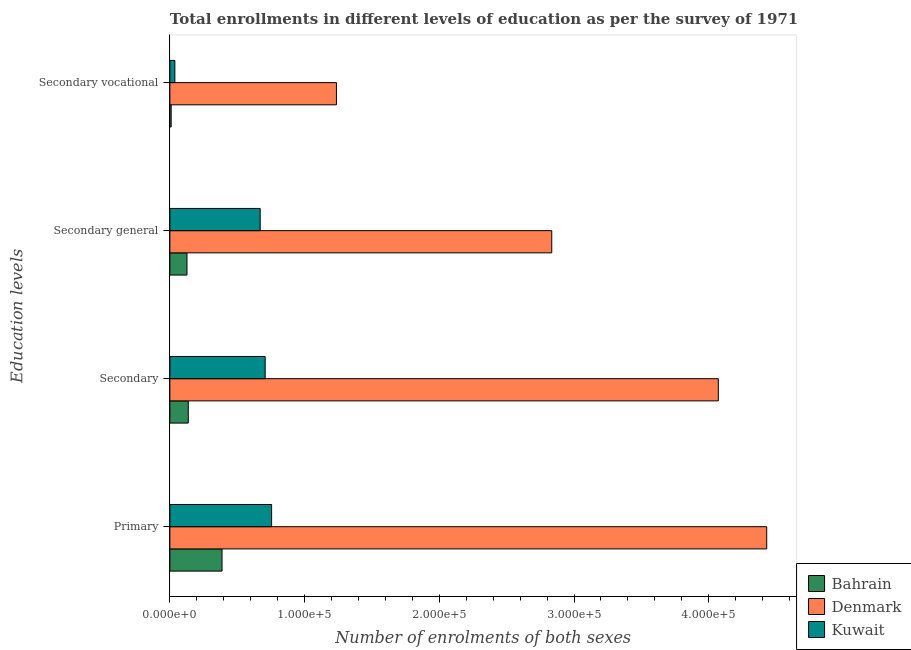How many different coloured bars are there?
Provide a succinct answer. 3. Are the number of bars per tick equal to the number of legend labels?
Make the answer very short. Yes. How many bars are there on the 3rd tick from the top?
Provide a succinct answer. 3. How many bars are there on the 3rd tick from the bottom?
Give a very brief answer. 3. What is the label of the 2nd group of bars from the top?
Give a very brief answer. Secondary general. What is the number of enrolments in secondary vocational education in Bahrain?
Ensure brevity in your answer.  955. Across all countries, what is the maximum number of enrolments in secondary general education?
Offer a very short reply. 2.83e+05. Across all countries, what is the minimum number of enrolments in secondary general education?
Your response must be concise. 1.27e+04. In which country was the number of enrolments in secondary vocational education maximum?
Your answer should be very brief. Denmark. In which country was the number of enrolments in primary education minimum?
Offer a very short reply. Bahrain. What is the total number of enrolments in secondary general education in the graph?
Make the answer very short. 3.63e+05. What is the difference between the number of enrolments in secondary vocational education in Bahrain and that in Kuwait?
Keep it short and to the point. -2741. What is the difference between the number of enrolments in secondary general education in Kuwait and the number of enrolments in secondary education in Denmark?
Keep it short and to the point. -3.40e+05. What is the average number of enrolments in primary education per country?
Provide a succinct answer. 1.86e+05. What is the difference between the number of enrolments in secondary general education and number of enrolments in primary education in Kuwait?
Offer a very short reply. -8475. In how many countries, is the number of enrolments in secondary general education greater than 320000 ?
Provide a short and direct response. 0. What is the ratio of the number of enrolments in secondary general education in Kuwait to that in Bahrain?
Give a very brief answer. 5.28. Is the number of enrolments in secondary education in Denmark less than that in Kuwait?
Give a very brief answer. No. Is the difference between the number of enrolments in secondary education in Bahrain and Denmark greater than the difference between the number of enrolments in primary education in Bahrain and Denmark?
Offer a very short reply. Yes. What is the difference between the highest and the second highest number of enrolments in secondary education?
Your answer should be very brief. 3.36e+05. What is the difference between the highest and the lowest number of enrolments in secondary general education?
Your answer should be very brief. 2.71e+05. In how many countries, is the number of enrolments in secondary education greater than the average number of enrolments in secondary education taken over all countries?
Provide a succinct answer. 1. Is the sum of the number of enrolments in secondary general education in Bahrain and Denmark greater than the maximum number of enrolments in primary education across all countries?
Offer a terse response. No. What does the 3rd bar from the top in Primary represents?
Your answer should be very brief. Bahrain. What does the 3rd bar from the bottom in Secondary general represents?
Ensure brevity in your answer.  Kuwait. Is it the case that in every country, the sum of the number of enrolments in primary education and number of enrolments in secondary education is greater than the number of enrolments in secondary general education?
Your response must be concise. Yes. How many bars are there?
Provide a short and direct response. 12. Are all the bars in the graph horizontal?
Keep it short and to the point. Yes. How many countries are there in the graph?
Offer a terse response. 3. What is the difference between two consecutive major ticks on the X-axis?
Give a very brief answer. 1.00e+05. Does the graph contain any zero values?
Offer a very short reply. No. How many legend labels are there?
Offer a very short reply. 3. What is the title of the graph?
Keep it short and to the point. Total enrollments in different levels of education as per the survey of 1971. What is the label or title of the X-axis?
Keep it short and to the point. Number of enrolments of both sexes. What is the label or title of the Y-axis?
Make the answer very short. Education levels. What is the Number of enrolments of both sexes in Bahrain in Primary?
Ensure brevity in your answer.  3.87e+04. What is the Number of enrolments of both sexes of Denmark in Primary?
Provide a short and direct response. 4.43e+05. What is the Number of enrolments of both sexes in Kuwait in Primary?
Give a very brief answer. 7.55e+04. What is the Number of enrolments of both sexes of Bahrain in Secondary?
Give a very brief answer. 1.37e+04. What is the Number of enrolments of both sexes of Denmark in Secondary?
Offer a very short reply. 4.07e+05. What is the Number of enrolments of both sexes in Kuwait in Secondary?
Make the answer very short. 7.07e+04. What is the Number of enrolments of both sexes of Bahrain in Secondary general?
Your response must be concise. 1.27e+04. What is the Number of enrolments of both sexes in Denmark in Secondary general?
Provide a succinct answer. 2.83e+05. What is the Number of enrolments of both sexes in Kuwait in Secondary general?
Ensure brevity in your answer.  6.70e+04. What is the Number of enrolments of both sexes in Bahrain in Secondary vocational?
Offer a terse response. 955. What is the Number of enrolments of both sexes of Denmark in Secondary vocational?
Your response must be concise. 1.24e+05. What is the Number of enrolments of both sexes in Kuwait in Secondary vocational?
Provide a short and direct response. 3696. Across all Education levels, what is the maximum Number of enrolments of both sexes in Bahrain?
Your response must be concise. 3.87e+04. Across all Education levels, what is the maximum Number of enrolments of both sexes of Denmark?
Ensure brevity in your answer.  4.43e+05. Across all Education levels, what is the maximum Number of enrolments of both sexes in Kuwait?
Provide a succinct answer. 7.55e+04. Across all Education levels, what is the minimum Number of enrolments of both sexes of Bahrain?
Your answer should be very brief. 955. Across all Education levels, what is the minimum Number of enrolments of both sexes in Denmark?
Make the answer very short. 1.24e+05. Across all Education levels, what is the minimum Number of enrolments of both sexes in Kuwait?
Provide a short and direct response. 3696. What is the total Number of enrolments of both sexes of Bahrain in the graph?
Offer a terse response. 6.60e+04. What is the total Number of enrolments of both sexes of Denmark in the graph?
Your answer should be very brief. 1.26e+06. What is the total Number of enrolments of both sexes in Kuwait in the graph?
Keep it short and to the point. 2.17e+05. What is the difference between the Number of enrolments of both sexes in Bahrain in Primary and that in Secondary?
Your answer should be compact. 2.51e+04. What is the difference between the Number of enrolments of both sexes in Denmark in Primary and that in Secondary?
Your response must be concise. 3.59e+04. What is the difference between the Number of enrolments of both sexes in Kuwait in Primary and that in Secondary?
Provide a short and direct response. 4779. What is the difference between the Number of enrolments of both sexes of Bahrain in Primary and that in Secondary general?
Keep it short and to the point. 2.60e+04. What is the difference between the Number of enrolments of both sexes in Denmark in Primary and that in Secondary general?
Your answer should be compact. 1.60e+05. What is the difference between the Number of enrolments of both sexes of Kuwait in Primary and that in Secondary general?
Your answer should be very brief. 8475. What is the difference between the Number of enrolments of both sexes in Bahrain in Primary and that in Secondary vocational?
Provide a succinct answer. 3.78e+04. What is the difference between the Number of enrolments of both sexes of Denmark in Primary and that in Secondary vocational?
Your answer should be very brief. 3.19e+05. What is the difference between the Number of enrolments of both sexes in Kuwait in Primary and that in Secondary vocational?
Keep it short and to the point. 7.18e+04. What is the difference between the Number of enrolments of both sexes in Bahrain in Secondary and that in Secondary general?
Your answer should be very brief. 955. What is the difference between the Number of enrolments of both sexes of Denmark in Secondary and that in Secondary general?
Your answer should be very brief. 1.24e+05. What is the difference between the Number of enrolments of both sexes of Kuwait in Secondary and that in Secondary general?
Provide a short and direct response. 3696. What is the difference between the Number of enrolments of both sexes in Bahrain in Secondary and that in Secondary vocational?
Your answer should be compact. 1.27e+04. What is the difference between the Number of enrolments of both sexes in Denmark in Secondary and that in Secondary vocational?
Your answer should be very brief. 2.83e+05. What is the difference between the Number of enrolments of both sexes of Kuwait in Secondary and that in Secondary vocational?
Offer a very short reply. 6.70e+04. What is the difference between the Number of enrolments of both sexes in Bahrain in Secondary general and that in Secondary vocational?
Your answer should be very brief. 1.17e+04. What is the difference between the Number of enrolments of both sexes of Denmark in Secondary general and that in Secondary vocational?
Ensure brevity in your answer.  1.60e+05. What is the difference between the Number of enrolments of both sexes in Kuwait in Secondary general and that in Secondary vocational?
Keep it short and to the point. 6.33e+04. What is the difference between the Number of enrolments of both sexes of Bahrain in Primary and the Number of enrolments of both sexes of Denmark in Secondary?
Make the answer very short. -3.68e+05. What is the difference between the Number of enrolments of both sexes in Bahrain in Primary and the Number of enrolments of both sexes in Kuwait in Secondary?
Ensure brevity in your answer.  -3.20e+04. What is the difference between the Number of enrolments of both sexes in Denmark in Primary and the Number of enrolments of both sexes in Kuwait in Secondary?
Ensure brevity in your answer.  3.72e+05. What is the difference between the Number of enrolments of both sexes of Bahrain in Primary and the Number of enrolments of both sexes of Denmark in Secondary general?
Your answer should be compact. -2.45e+05. What is the difference between the Number of enrolments of both sexes of Bahrain in Primary and the Number of enrolments of both sexes of Kuwait in Secondary general?
Keep it short and to the point. -2.83e+04. What is the difference between the Number of enrolments of both sexes in Denmark in Primary and the Number of enrolments of both sexes in Kuwait in Secondary general?
Provide a succinct answer. 3.76e+05. What is the difference between the Number of enrolments of both sexes of Bahrain in Primary and the Number of enrolments of both sexes of Denmark in Secondary vocational?
Your answer should be compact. -8.49e+04. What is the difference between the Number of enrolments of both sexes of Bahrain in Primary and the Number of enrolments of both sexes of Kuwait in Secondary vocational?
Your answer should be very brief. 3.50e+04. What is the difference between the Number of enrolments of both sexes of Denmark in Primary and the Number of enrolments of both sexes of Kuwait in Secondary vocational?
Give a very brief answer. 4.39e+05. What is the difference between the Number of enrolments of both sexes in Bahrain in Secondary and the Number of enrolments of both sexes in Denmark in Secondary general?
Provide a succinct answer. -2.70e+05. What is the difference between the Number of enrolments of both sexes in Bahrain in Secondary and the Number of enrolments of both sexes in Kuwait in Secondary general?
Offer a terse response. -5.34e+04. What is the difference between the Number of enrolments of both sexes of Denmark in Secondary and the Number of enrolments of both sexes of Kuwait in Secondary general?
Make the answer very short. 3.40e+05. What is the difference between the Number of enrolments of both sexes in Bahrain in Secondary and the Number of enrolments of both sexes in Denmark in Secondary vocational?
Make the answer very short. -1.10e+05. What is the difference between the Number of enrolments of both sexes of Bahrain in Secondary and the Number of enrolments of both sexes of Kuwait in Secondary vocational?
Offer a very short reply. 9956. What is the difference between the Number of enrolments of both sexes in Denmark in Secondary and the Number of enrolments of both sexes in Kuwait in Secondary vocational?
Offer a terse response. 4.03e+05. What is the difference between the Number of enrolments of both sexes in Bahrain in Secondary general and the Number of enrolments of both sexes in Denmark in Secondary vocational?
Offer a very short reply. -1.11e+05. What is the difference between the Number of enrolments of both sexes of Bahrain in Secondary general and the Number of enrolments of both sexes of Kuwait in Secondary vocational?
Provide a succinct answer. 9001. What is the difference between the Number of enrolments of both sexes in Denmark in Secondary general and the Number of enrolments of both sexes in Kuwait in Secondary vocational?
Ensure brevity in your answer.  2.80e+05. What is the average Number of enrolments of both sexes in Bahrain per Education levels?
Give a very brief answer. 1.65e+04. What is the average Number of enrolments of both sexes in Denmark per Education levels?
Ensure brevity in your answer.  3.14e+05. What is the average Number of enrolments of both sexes in Kuwait per Education levels?
Give a very brief answer. 5.42e+04. What is the difference between the Number of enrolments of both sexes of Bahrain and Number of enrolments of both sexes of Denmark in Primary?
Make the answer very short. -4.04e+05. What is the difference between the Number of enrolments of both sexes of Bahrain and Number of enrolments of both sexes of Kuwait in Primary?
Ensure brevity in your answer.  -3.68e+04. What is the difference between the Number of enrolments of both sexes in Denmark and Number of enrolments of both sexes in Kuwait in Primary?
Keep it short and to the point. 3.68e+05. What is the difference between the Number of enrolments of both sexes of Bahrain and Number of enrolments of both sexes of Denmark in Secondary?
Make the answer very short. -3.93e+05. What is the difference between the Number of enrolments of both sexes in Bahrain and Number of enrolments of both sexes in Kuwait in Secondary?
Ensure brevity in your answer.  -5.71e+04. What is the difference between the Number of enrolments of both sexes in Denmark and Number of enrolments of both sexes in Kuwait in Secondary?
Offer a terse response. 3.36e+05. What is the difference between the Number of enrolments of both sexes of Bahrain and Number of enrolments of both sexes of Denmark in Secondary general?
Your answer should be compact. -2.71e+05. What is the difference between the Number of enrolments of both sexes of Bahrain and Number of enrolments of both sexes of Kuwait in Secondary general?
Keep it short and to the point. -5.43e+04. What is the difference between the Number of enrolments of both sexes in Denmark and Number of enrolments of both sexes in Kuwait in Secondary general?
Your answer should be very brief. 2.16e+05. What is the difference between the Number of enrolments of both sexes in Bahrain and Number of enrolments of both sexes in Denmark in Secondary vocational?
Offer a very short reply. -1.23e+05. What is the difference between the Number of enrolments of both sexes in Bahrain and Number of enrolments of both sexes in Kuwait in Secondary vocational?
Your answer should be compact. -2741. What is the difference between the Number of enrolments of both sexes of Denmark and Number of enrolments of both sexes of Kuwait in Secondary vocational?
Give a very brief answer. 1.20e+05. What is the ratio of the Number of enrolments of both sexes in Bahrain in Primary to that in Secondary?
Keep it short and to the point. 2.84. What is the ratio of the Number of enrolments of both sexes in Denmark in Primary to that in Secondary?
Your answer should be very brief. 1.09. What is the ratio of the Number of enrolments of both sexes of Kuwait in Primary to that in Secondary?
Keep it short and to the point. 1.07. What is the ratio of the Number of enrolments of both sexes in Bahrain in Primary to that in Secondary general?
Provide a succinct answer. 3.05. What is the ratio of the Number of enrolments of both sexes of Denmark in Primary to that in Secondary general?
Your response must be concise. 1.56. What is the ratio of the Number of enrolments of both sexes in Kuwait in Primary to that in Secondary general?
Offer a terse response. 1.13. What is the ratio of the Number of enrolments of both sexes of Bahrain in Primary to that in Secondary vocational?
Make the answer very short. 40.54. What is the ratio of the Number of enrolments of both sexes of Denmark in Primary to that in Secondary vocational?
Provide a short and direct response. 3.58. What is the ratio of the Number of enrolments of both sexes in Kuwait in Primary to that in Secondary vocational?
Ensure brevity in your answer.  20.43. What is the ratio of the Number of enrolments of both sexes in Bahrain in Secondary to that in Secondary general?
Ensure brevity in your answer.  1.08. What is the ratio of the Number of enrolments of both sexes in Denmark in Secondary to that in Secondary general?
Ensure brevity in your answer.  1.44. What is the ratio of the Number of enrolments of both sexes in Kuwait in Secondary to that in Secondary general?
Your answer should be very brief. 1.06. What is the ratio of the Number of enrolments of both sexes in Bahrain in Secondary to that in Secondary vocational?
Offer a very short reply. 14.3. What is the ratio of the Number of enrolments of both sexes of Denmark in Secondary to that in Secondary vocational?
Provide a succinct answer. 3.29. What is the ratio of the Number of enrolments of both sexes of Kuwait in Secondary to that in Secondary vocational?
Give a very brief answer. 19.14. What is the ratio of the Number of enrolments of both sexes of Bahrain in Secondary general to that in Secondary vocational?
Your answer should be compact. 13.3. What is the ratio of the Number of enrolments of both sexes in Denmark in Secondary general to that in Secondary vocational?
Your response must be concise. 2.29. What is the ratio of the Number of enrolments of both sexes in Kuwait in Secondary general to that in Secondary vocational?
Offer a terse response. 18.14. What is the difference between the highest and the second highest Number of enrolments of both sexes in Bahrain?
Your answer should be compact. 2.51e+04. What is the difference between the highest and the second highest Number of enrolments of both sexes of Denmark?
Provide a short and direct response. 3.59e+04. What is the difference between the highest and the second highest Number of enrolments of both sexes of Kuwait?
Your answer should be very brief. 4779. What is the difference between the highest and the lowest Number of enrolments of both sexes of Bahrain?
Offer a terse response. 3.78e+04. What is the difference between the highest and the lowest Number of enrolments of both sexes of Denmark?
Ensure brevity in your answer.  3.19e+05. What is the difference between the highest and the lowest Number of enrolments of both sexes in Kuwait?
Provide a succinct answer. 7.18e+04. 